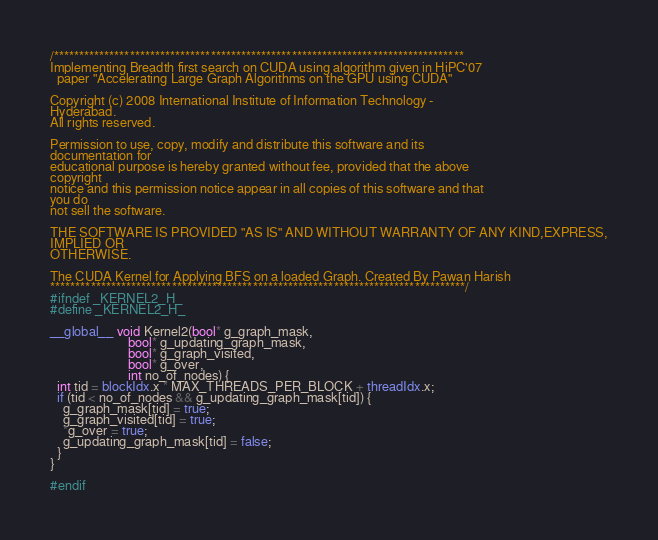Convert code to text. <code><loc_0><loc_0><loc_500><loc_500><_Cuda_>/*********************************************************************************
Implementing Breadth first search on CUDA using algorithm given in HiPC'07
  paper "Accelerating Large Graph Algorithms on the GPU using CUDA"

Copyright (c) 2008 International Institute of Information Technology -
Hyderabad.
All rights reserved.

Permission to use, copy, modify and distribute this software and its
documentation for
educational purpose is hereby granted without fee, provided that the above
copyright
notice and this permission notice appear in all copies of this software and that
you do
not sell the software.

THE SOFTWARE IS PROVIDED "AS IS" AND WITHOUT WARRANTY OF ANY KIND,EXPRESS,
IMPLIED OR
OTHERWISE.

The CUDA Kernel for Applying BFS on a loaded Graph. Created By Pawan Harish
**********************************************************************************/
#ifndef _KERNEL2_H_
#define _KERNEL2_H_

__global__ void Kernel2(bool* g_graph_mask,
                        bool* g_updating_graph_mask,
                        bool* g_graph_visited,
                        bool* g_over,
                        int no_of_nodes) {
  int tid = blockIdx.x * MAX_THREADS_PER_BLOCK + threadIdx.x;
  if (tid < no_of_nodes && g_updating_graph_mask[tid]) {
    g_graph_mask[tid] = true;
    g_graph_visited[tid] = true;
    *g_over = true;
    g_updating_graph_mask[tid] = false;
  }
}

#endif
</code> 